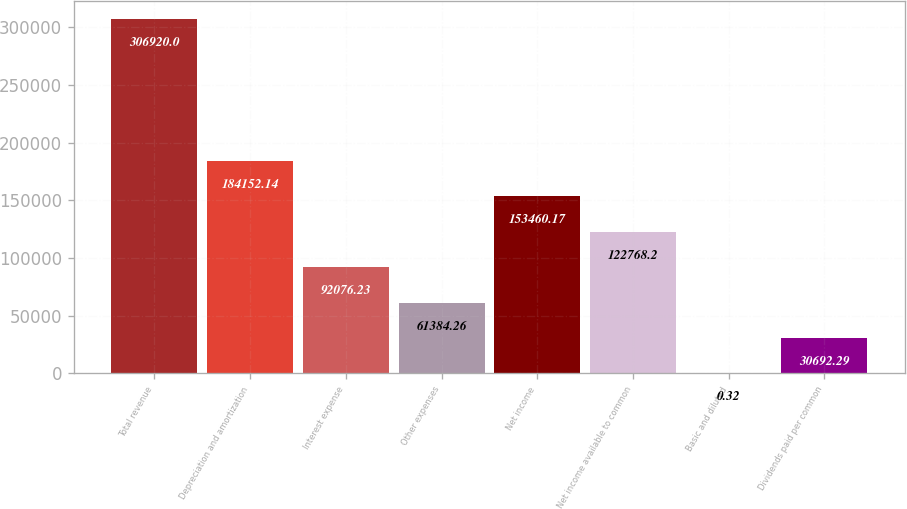Convert chart to OTSL. <chart><loc_0><loc_0><loc_500><loc_500><bar_chart><fcel>Total revenue<fcel>Depreciation and amortization<fcel>Interest expense<fcel>Other expenses<fcel>Net income<fcel>Net income available to common<fcel>Basic and diluted<fcel>Dividends paid per common<nl><fcel>306920<fcel>184152<fcel>92076.2<fcel>61384.3<fcel>153460<fcel>122768<fcel>0.32<fcel>30692.3<nl></chart> 